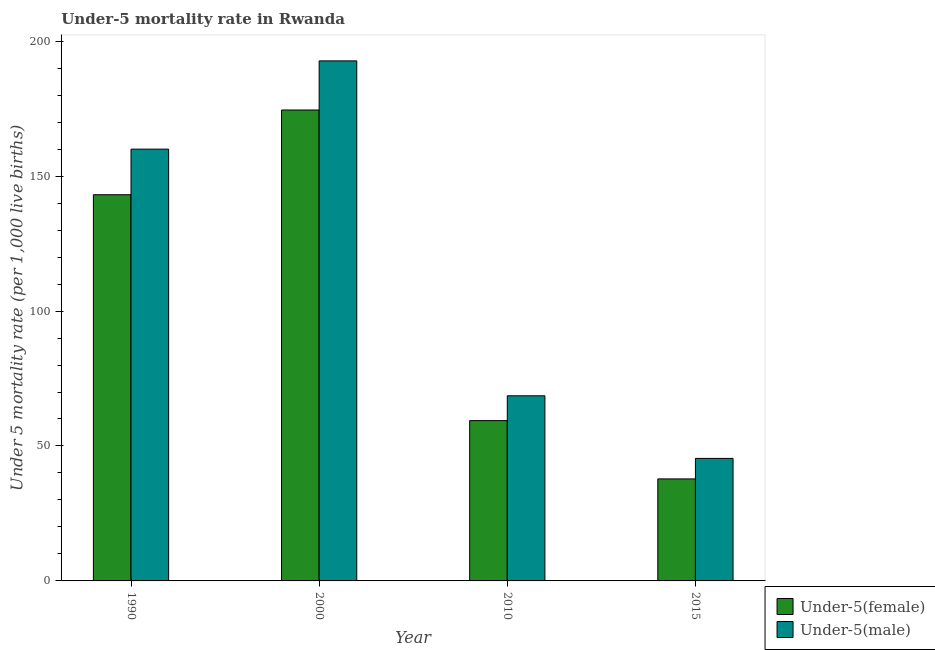How many different coloured bars are there?
Your answer should be compact. 2. Are the number of bars per tick equal to the number of legend labels?
Provide a succinct answer. Yes. How many bars are there on the 1st tick from the left?
Provide a short and direct response. 2. What is the label of the 1st group of bars from the left?
Make the answer very short. 1990. In how many cases, is the number of bars for a given year not equal to the number of legend labels?
Your response must be concise. 0. What is the under-5 male mortality rate in 2000?
Provide a short and direct response. 192.7. Across all years, what is the maximum under-5 female mortality rate?
Make the answer very short. 174.5. Across all years, what is the minimum under-5 male mortality rate?
Make the answer very short. 45.4. In which year was the under-5 female mortality rate minimum?
Ensure brevity in your answer.  2015. What is the total under-5 male mortality rate in the graph?
Ensure brevity in your answer.  466.7. What is the difference between the under-5 female mortality rate in 1990 and that in 2010?
Keep it short and to the point. 83.7. What is the difference between the under-5 female mortality rate in 2000 and the under-5 male mortality rate in 2010?
Offer a very short reply. 115.1. What is the average under-5 female mortality rate per year?
Your answer should be compact. 103.7. In how many years, is the under-5 male mortality rate greater than 50?
Provide a short and direct response. 3. What is the ratio of the under-5 male mortality rate in 1990 to that in 2000?
Your response must be concise. 0.83. Is the under-5 male mortality rate in 2010 less than that in 2015?
Give a very brief answer. No. What is the difference between the highest and the second highest under-5 male mortality rate?
Provide a succinct answer. 32.7. What is the difference between the highest and the lowest under-5 male mortality rate?
Ensure brevity in your answer.  147.3. In how many years, is the under-5 female mortality rate greater than the average under-5 female mortality rate taken over all years?
Your answer should be compact. 2. Is the sum of the under-5 female mortality rate in 1990 and 2000 greater than the maximum under-5 male mortality rate across all years?
Give a very brief answer. Yes. What does the 1st bar from the left in 2015 represents?
Provide a short and direct response. Under-5(female). What does the 2nd bar from the right in 1990 represents?
Offer a very short reply. Under-5(female). How many years are there in the graph?
Offer a terse response. 4. Are the values on the major ticks of Y-axis written in scientific E-notation?
Offer a very short reply. No. Does the graph contain any zero values?
Your response must be concise. No. Does the graph contain grids?
Your answer should be compact. No. Where does the legend appear in the graph?
Your response must be concise. Bottom right. How are the legend labels stacked?
Make the answer very short. Vertical. What is the title of the graph?
Offer a terse response. Under-5 mortality rate in Rwanda. What is the label or title of the X-axis?
Your response must be concise. Year. What is the label or title of the Y-axis?
Your response must be concise. Under 5 mortality rate (per 1,0 live births). What is the Under 5 mortality rate (per 1,000 live births) of Under-5(female) in 1990?
Make the answer very short. 143.1. What is the Under 5 mortality rate (per 1,000 live births) in Under-5(male) in 1990?
Keep it short and to the point. 160. What is the Under 5 mortality rate (per 1,000 live births) in Under-5(female) in 2000?
Make the answer very short. 174.5. What is the Under 5 mortality rate (per 1,000 live births) of Under-5(male) in 2000?
Make the answer very short. 192.7. What is the Under 5 mortality rate (per 1,000 live births) in Under-5(female) in 2010?
Keep it short and to the point. 59.4. What is the Under 5 mortality rate (per 1,000 live births) of Under-5(male) in 2010?
Give a very brief answer. 68.6. What is the Under 5 mortality rate (per 1,000 live births) in Under-5(female) in 2015?
Your answer should be very brief. 37.8. What is the Under 5 mortality rate (per 1,000 live births) of Under-5(male) in 2015?
Ensure brevity in your answer.  45.4. Across all years, what is the maximum Under 5 mortality rate (per 1,000 live births) in Under-5(female)?
Your answer should be compact. 174.5. Across all years, what is the maximum Under 5 mortality rate (per 1,000 live births) of Under-5(male)?
Offer a terse response. 192.7. Across all years, what is the minimum Under 5 mortality rate (per 1,000 live births) of Under-5(female)?
Offer a terse response. 37.8. Across all years, what is the minimum Under 5 mortality rate (per 1,000 live births) in Under-5(male)?
Ensure brevity in your answer.  45.4. What is the total Under 5 mortality rate (per 1,000 live births) of Under-5(female) in the graph?
Your answer should be very brief. 414.8. What is the total Under 5 mortality rate (per 1,000 live births) in Under-5(male) in the graph?
Keep it short and to the point. 466.7. What is the difference between the Under 5 mortality rate (per 1,000 live births) in Under-5(female) in 1990 and that in 2000?
Keep it short and to the point. -31.4. What is the difference between the Under 5 mortality rate (per 1,000 live births) of Under-5(male) in 1990 and that in 2000?
Provide a short and direct response. -32.7. What is the difference between the Under 5 mortality rate (per 1,000 live births) in Under-5(female) in 1990 and that in 2010?
Offer a very short reply. 83.7. What is the difference between the Under 5 mortality rate (per 1,000 live births) in Under-5(male) in 1990 and that in 2010?
Give a very brief answer. 91.4. What is the difference between the Under 5 mortality rate (per 1,000 live births) in Under-5(female) in 1990 and that in 2015?
Provide a short and direct response. 105.3. What is the difference between the Under 5 mortality rate (per 1,000 live births) in Under-5(male) in 1990 and that in 2015?
Give a very brief answer. 114.6. What is the difference between the Under 5 mortality rate (per 1,000 live births) in Under-5(female) in 2000 and that in 2010?
Make the answer very short. 115.1. What is the difference between the Under 5 mortality rate (per 1,000 live births) in Under-5(male) in 2000 and that in 2010?
Provide a succinct answer. 124.1. What is the difference between the Under 5 mortality rate (per 1,000 live births) in Under-5(female) in 2000 and that in 2015?
Give a very brief answer. 136.7. What is the difference between the Under 5 mortality rate (per 1,000 live births) of Under-5(male) in 2000 and that in 2015?
Make the answer very short. 147.3. What is the difference between the Under 5 mortality rate (per 1,000 live births) of Under-5(female) in 2010 and that in 2015?
Offer a very short reply. 21.6. What is the difference between the Under 5 mortality rate (per 1,000 live births) of Under-5(male) in 2010 and that in 2015?
Ensure brevity in your answer.  23.2. What is the difference between the Under 5 mortality rate (per 1,000 live births) of Under-5(female) in 1990 and the Under 5 mortality rate (per 1,000 live births) of Under-5(male) in 2000?
Provide a short and direct response. -49.6. What is the difference between the Under 5 mortality rate (per 1,000 live births) in Under-5(female) in 1990 and the Under 5 mortality rate (per 1,000 live births) in Under-5(male) in 2010?
Provide a short and direct response. 74.5. What is the difference between the Under 5 mortality rate (per 1,000 live births) in Under-5(female) in 1990 and the Under 5 mortality rate (per 1,000 live births) in Under-5(male) in 2015?
Give a very brief answer. 97.7. What is the difference between the Under 5 mortality rate (per 1,000 live births) in Under-5(female) in 2000 and the Under 5 mortality rate (per 1,000 live births) in Under-5(male) in 2010?
Your response must be concise. 105.9. What is the difference between the Under 5 mortality rate (per 1,000 live births) in Under-5(female) in 2000 and the Under 5 mortality rate (per 1,000 live births) in Under-5(male) in 2015?
Offer a terse response. 129.1. What is the difference between the Under 5 mortality rate (per 1,000 live births) in Under-5(female) in 2010 and the Under 5 mortality rate (per 1,000 live births) in Under-5(male) in 2015?
Ensure brevity in your answer.  14. What is the average Under 5 mortality rate (per 1,000 live births) in Under-5(female) per year?
Keep it short and to the point. 103.7. What is the average Under 5 mortality rate (per 1,000 live births) of Under-5(male) per year?
Your answer should be compact. 116.67. In the year 1990, what is the difference between the Under 5 mortality rate (per 1,000 live births) of Under-5(female) and Under 5 mortality rate (per 1,000 live births) of Under-5(male)?
Your answer should be compact. -16.9. In the year 2000, what is the difference between the Under 5 mortality rate (per 1,000 live births) in Under-5(female) and Under 5 mortality rate (per 1,000 live births) in Under-5(male)?
Provide a succinct answer. -18.2. What is the ratio of the Under 5 mortality rate (per 1,000 live births) in Under-5(female) in 1990 to that in 2000?
Offer a very short reply. 0.82. What is the ratio of the Under 5 mortality rate (per 1,000 live births) of Under-5(male) in 1990 to that in 2000?
Make the answer very short. 0.83. What is the ratio of the Under 5 mortality rate (per 1,000 live births) in Under-5(female) in 1990 to that in 2010?
Give a very brief answer. 2.41. What is the ratio of the Under 5 mortality rate (per 1,000 live births) in Under-5(male) in 1990 to that in 2010?
Provide a succinct answer. 2.33. What is the ratio of the Under 5 mortality rate (per 1,000 live births) in Under-5(female) in 1990 to that in 2015?
Your answer should be very brief. 3.79. What is the ratio of the Under 5 mortality rate (per 1,000 live births) in Under-5(male) in 1990 to that in 2015?
Your answer should be compact. 3.52. What is the ratio of the Under 5 mortality rate (per 1,000 live births) of Under-5(female) in 2000 to that in 2010?
Keep it short and to the point. 2.94. What is the ratio of the Under 5 mortality rate (per 1,000 live births) of Under-5(male) in 2000 to that in 2010?
Keep it short and to the point. 2.81. What is the ratio of the Under 5 mortality rate (per 1,000 live births) in Under-5(female) in 2000 to that in 2015?
Your answer should be very brief. 4.62. What is the ratio of the Under 5 mortality rate (per 1,000 live births) of Under-5(male) in 2000 to that in 2015?
Provide a short and direct response. 4.24. What is the ratio of the Under 5 mortality rate (per 1,000 live births) of Under-5(female) in 2010 to that in 2015?
Offer a terse response. 1.57. What is the ratio of the Under 5 mortality rate (per 1,000 live births) in Under-5(male) in 2010 to that in 2015?
Make the answer very short. 1.51. What is the difference between the highest and the second highest Under 5 mortality rate (per 1,000 live births) of Under-5(female)?
Offer a terse response. 31.4. What is the difference between the highest and the second highest Under 5 mortality rate (per 1,000 live births) of Under-5(male)?
Your answer should be very brief. 32.7. What is the difference between the highest and the lowest Under 5 mortality rate (per 1,000 live births) in Under-5(female)?
Make the answer very short. 136.7. What is the difference between the highest and the lowest Under 5 mortality rate (per 1,000 live births) of Under-5(male)?
Provide a succinct answer. 147.3. 